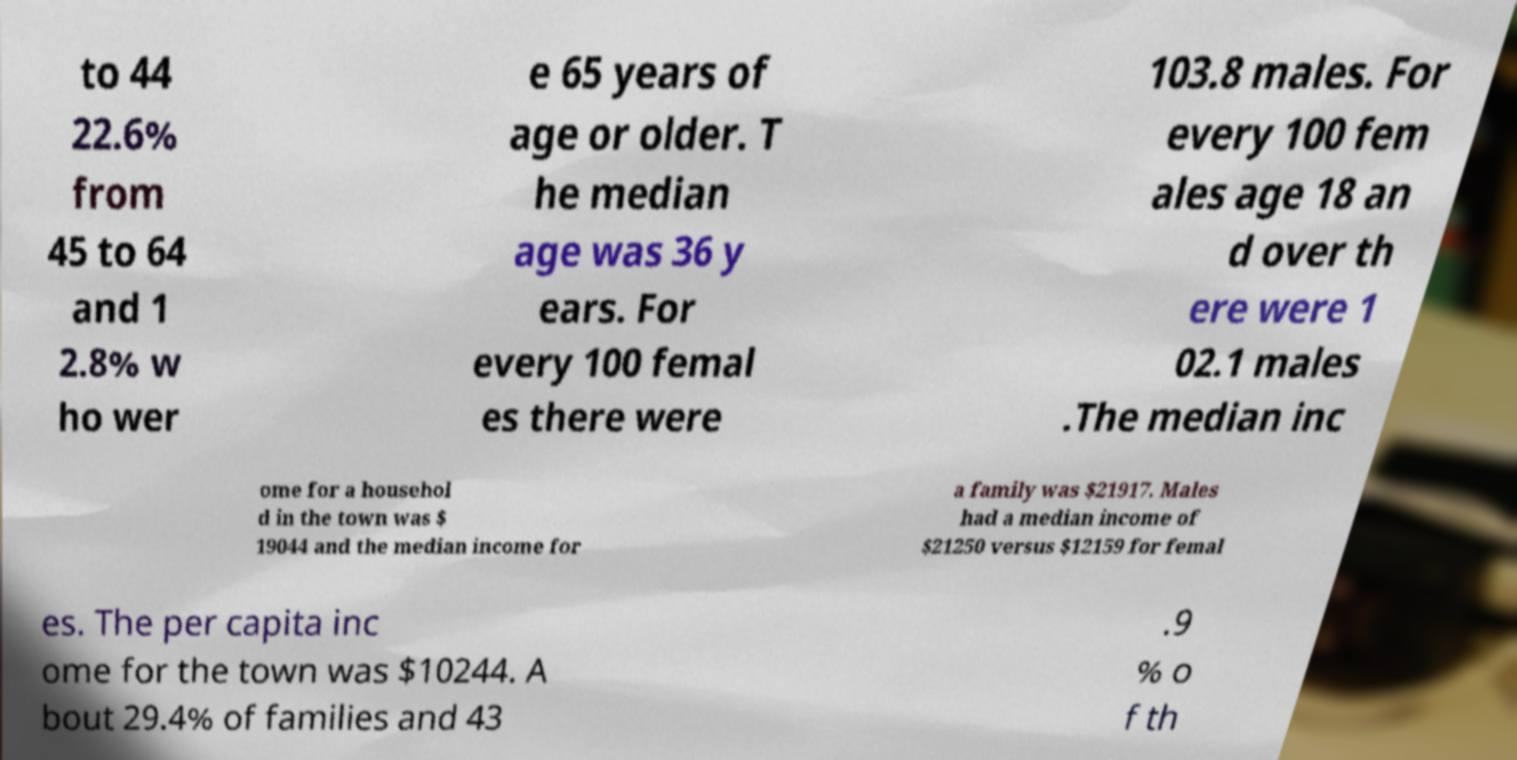Can you read and provide the text displayed in the image?This photo seems to have some interesting text. Can you extract and type it out for me? to 44 22.6% from 45 to 64 and 1 2.8% w ho wer e 65 years of age or older. T he median age was 36 y ears. For every 100 femal es there were 103.8 males. For every 100 fem ales age 18 an d over th ere were 1 02.1 males .The median inc ome for a househol d in the town was $ 19044 and the median income for a family was $21917. Males had a median income of $21250 versus $12159 for femal es. The per capita inc ome for the town was $10244. A bout 29.4% of families and 43 .9 % o f th 